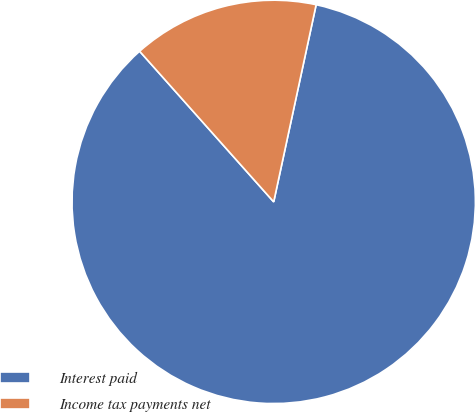Convert chart. <chart><loc_0><loc_0><loc_500><loc_500><pie_chart><fcel>Interest paid<fcel>Income tax payments net<nl><fcel>85.05%<fcel>14.95%<nl></chart> 